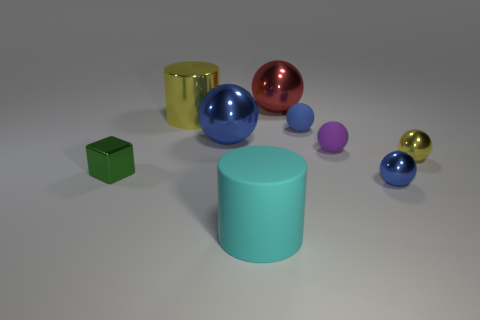Do the red thing and the purple ball have the same material?
Ensure brevity in your answer.  No. What number of green objects are made of the same material as the tiny purple thing?
Offer a very short reply. 0. The large cylinder that is made of the same material as the red thing is what color?
Your response must be concise. Yellow. The big red object is what shape?
Offer a very short reply. Sphere. What is the big cylinder right of the yellow cylinder made of?
Keep it short and to the point. Rubber. Are there any tiny objects that have the same color as the metallic cylinder?
Your answer should be compact. Yes. The red shiny object that is the same size as the metallic cylinder is what shape?
Make the answer very short. Sphere. What color is the large cylinder in front of the shiny block?
Your answer should be compact. Cyan. There is a shiny object behind the metallic cylinder; are there any big objects that are in front of it?
Give a very brief answer. Yes. What number of objects are balls that are on the left side of the large cyan object or big blue metal spheres?
Make the answer very short. 1. 